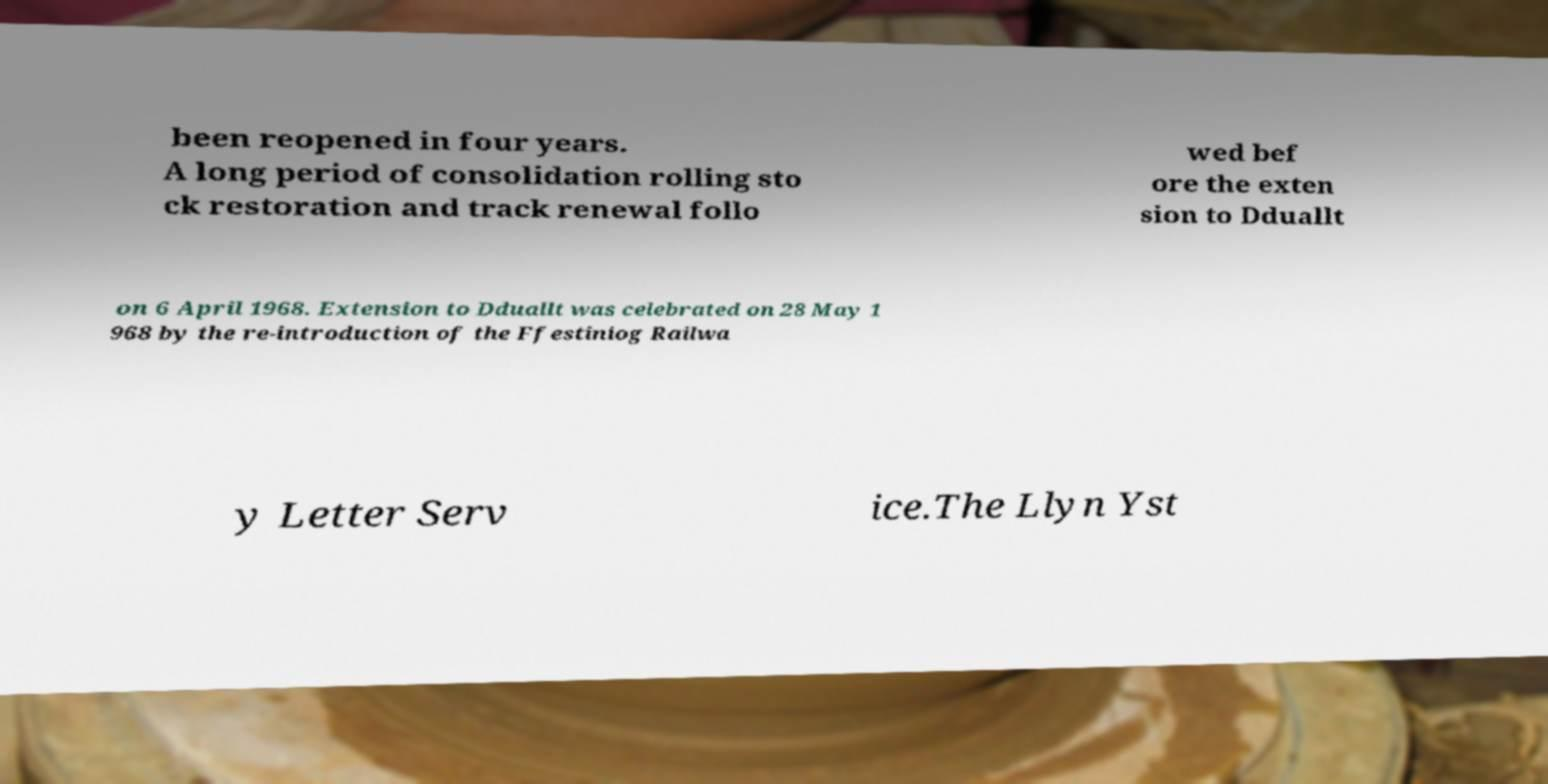Could you assist in decoding the text presented in this image and type it out clearly? been reopened in four years. A long period of consolidation rolling sto ck restoration and track renewal follo wed bef ore the exten sion to Dduallt on 6 April 1968. Extension to Dduallt was celebrated on 28 May 1 968 by the re-introduction of the Ffestiniog Railwa y Letter Serv ice.The Llyn Yst 